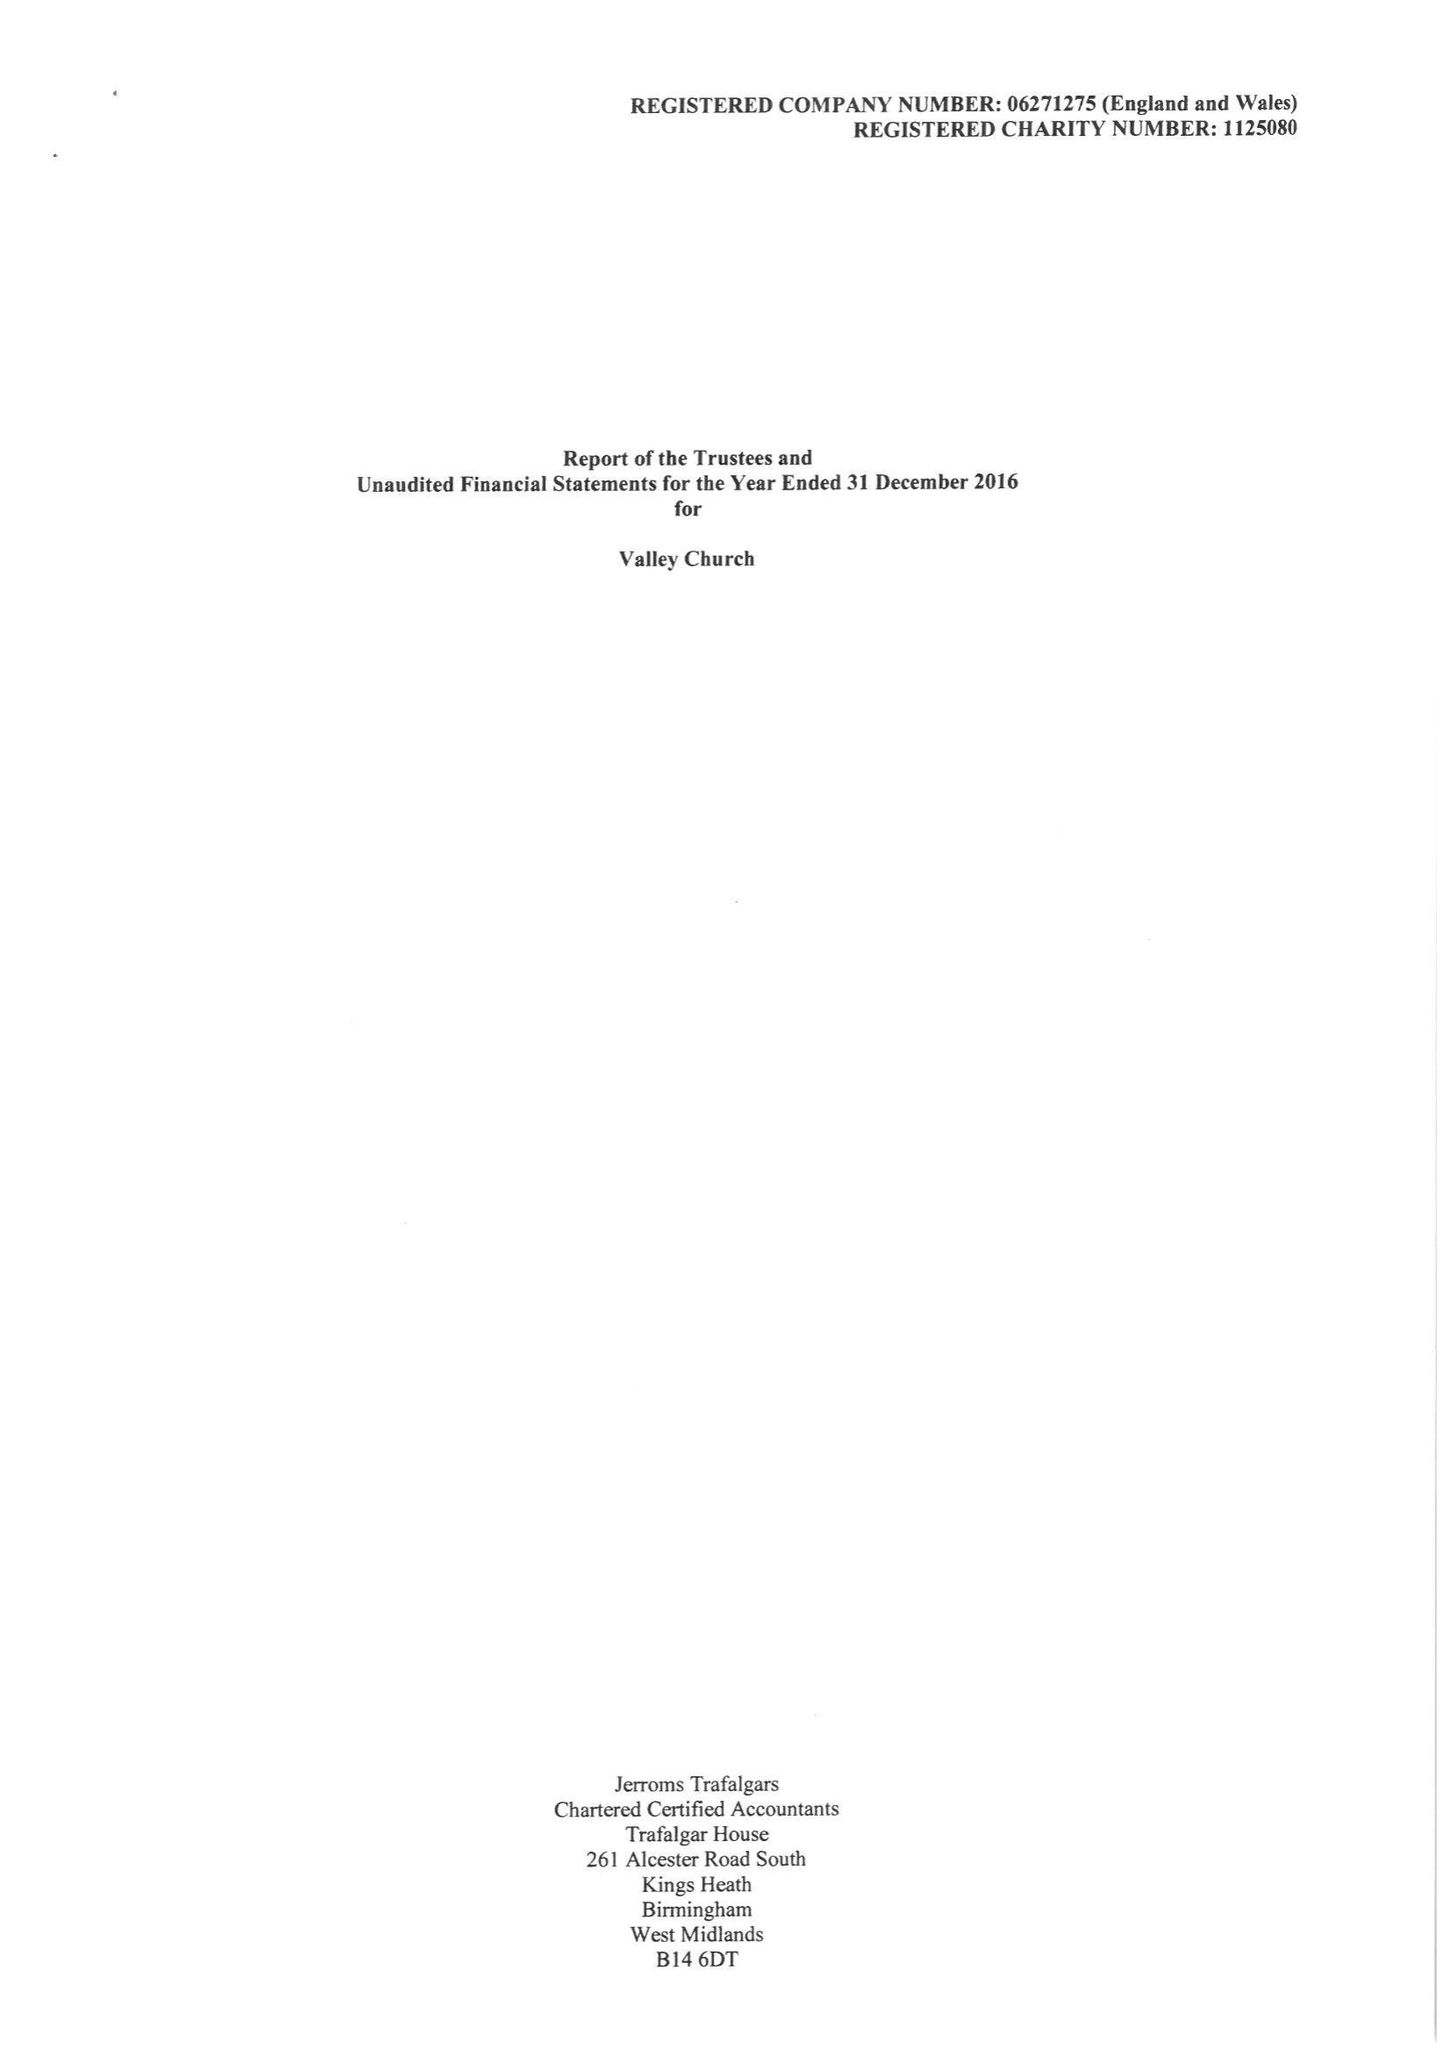What is the value for the address__postcode?
Answer the question using a single word or phrase. PR5 5TW 